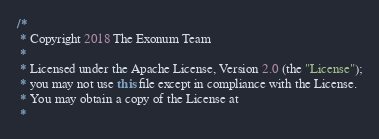Convert code to text. <code><loc_0><loc_0><loc_500><loc_500><_Java_>/* 
 * Copyright 2018 The Exonum Team
 *
 * Licensed under the Apache License, Version 2.0 (the "License");
 * you may not use this file except in compliance with the License.
 * You may obtain a copy of the License at
 *</code> 